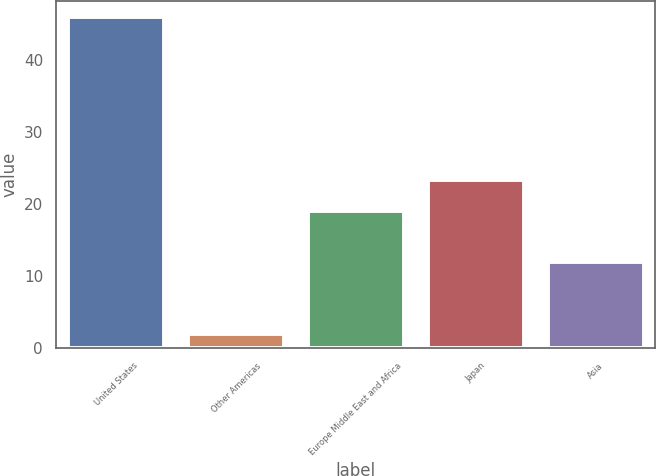Convert chart to OTSL. <chart><loc_0><loc_0><loc_500><loc_500><bar_chart><fcel>United States<fcel>Other Americas<fcel>Europe Middle East and Africa<fcel>Japan<fcel>Asia<nl><fcel>46<fcel>2<fcel>19<fcel>23.4<fcel>12<nl></chart> 